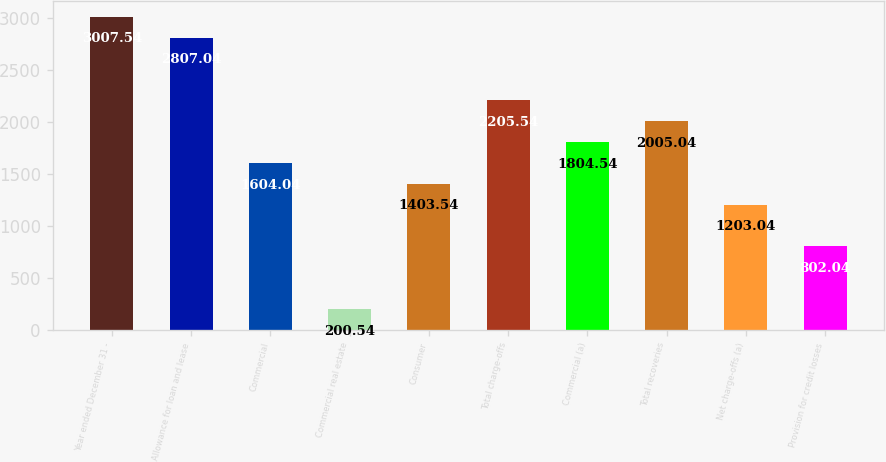<chart> <loc_0><loc_0><loc_500><loc_500><bar_chart><fcel>Year ended December 31 -<fcel>Allowance for loan and lease<fcel>Commercial<fcel>Commercial real estate<fcel>Consumer<fcel>Total charge-offs<fcel>Commercial (a)<fcel>Total recoveries<fcel>Net charge-offs (a)<fcel>Provision for credit losses<nl><fcel>3007.54<fcel>2807.04<fcel>1604.04<fcel>200.54<fcel>1403.54<fcel>2205.54<fcel>1804.54<fcel>2005.04<fcel>1203.04<fcel>802.04<nl></chart> 